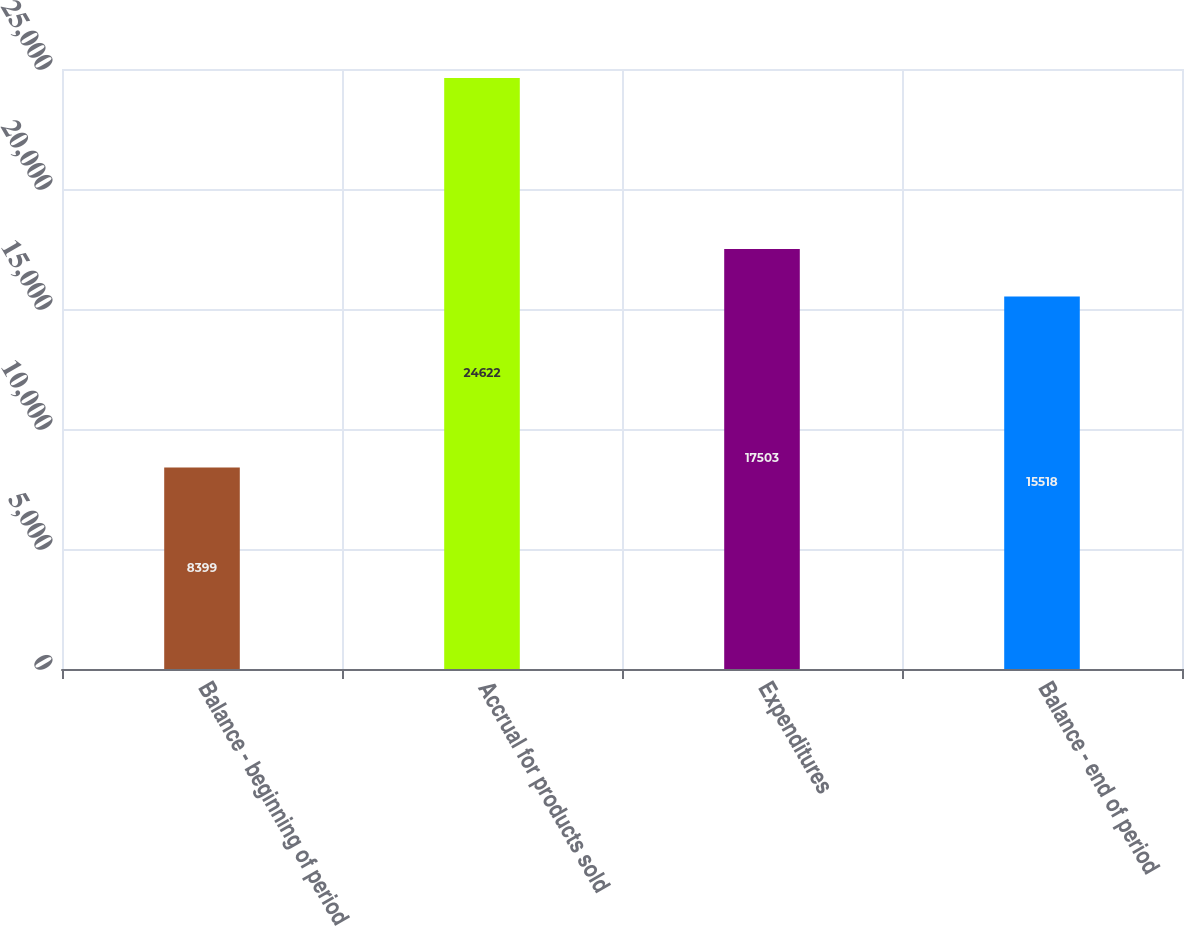Convert chart. <chart><loc_0><loc_0><loc_500><loc_500><bar_chart><fcel>Balance - beginning of period<fcel>Accrual for products sold<fcel>Expenditures<fcel>Balance - end of period<nl><fcel>8399<fcel>24622<fcel>17503<fcel>15518<nl></chart> 